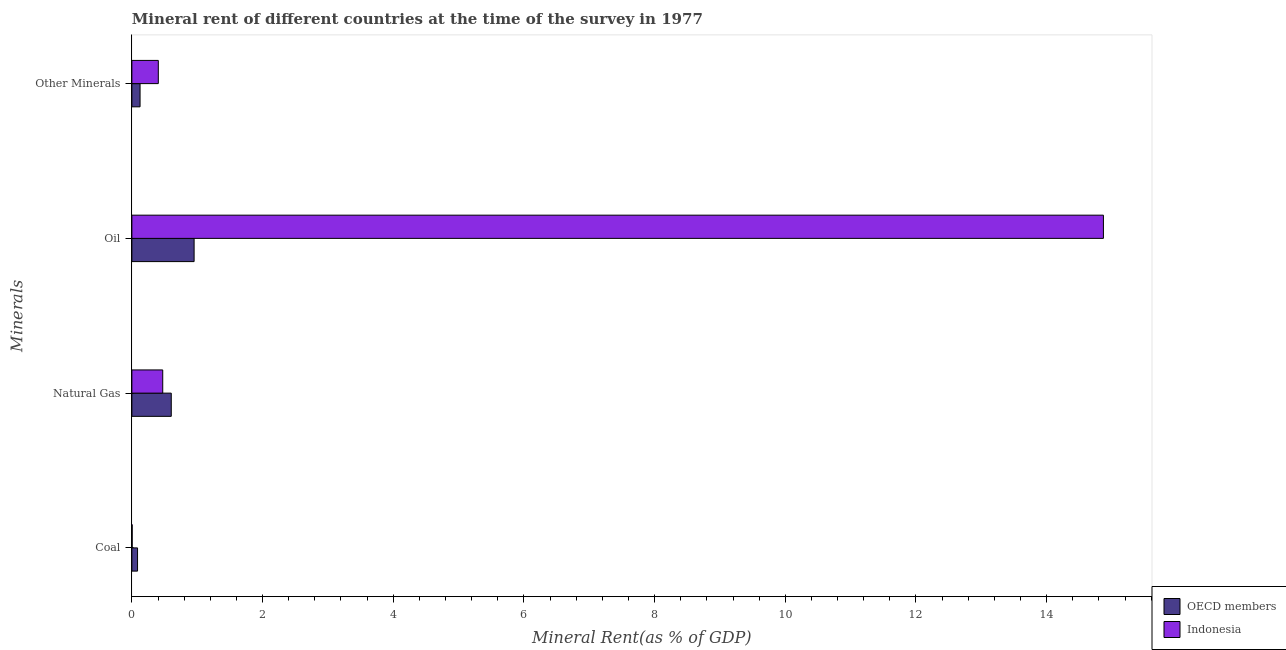How many groups of bars are there?
Offer a very short reply. 4. How many bars are there on the 3rd tick from the top?
Provide a short and direct response. 2. What is the label of the 1st group of bars from the top?
Your answer should be compact. Other Minerals. What is the natural gas rent in OECD members?
Your response must be concise. 0.6. Across all countries, what is the maximum natural gas rent?
Provide a short and direct response. 0.6. Across all countries, what is the minimum oil rent?
Provide a short and direct response. 0.95. In which country was the oil rent maximum?
Keep it short and to the point. Indonesia. What is the total coal rent in the graph?
Your response must be concise. 0.09. What is the difference between the  rent of other minerals in OECD members and that in Indonesia?
Make the answer very short. -0.28. What is the difference between the coal rent in OECD members and the oil rent in Indonesia?
Keep it short and to the point. -14.78. What is the average oil rent per country?
Offer a very short reply. 7.91. What is the difference between the  rent of other minerals and oil rent in Indonesia?
Your answer should be compact. -14.46. What is the ratio of the oil rent in Indonesia to that in OECD members?
Your response must be concise. 15.61. What is the difference between the highest and the second highest  rent of other minerals?
Offer a very short reply. 0.28. What is the difference between the highest and the lowest  rent of other minerals?
Give a very brief answer. 0.28. What does the 2nd bar from the top in Oil represents?
Provide a succinct answer. OECD members. Is it the case that in every country, the sum of the coal rent and natural gas rent is greater than the oil rent?
Your response must be concise. No. How many bars are there?
Offer a very short reply. 8. How many countries are there in the graph?
Keep it short and to the point. 2. Are the values on the major ticks of X-axis written in scientific E-notation?
Give a very brief answer. No. Does the graph contain any zero values?
Your answer should be very brief. No. How are the legend labels stacked?
Provide a succinct answer. Vertical. What is the title of the graph?
Your response must be concise. Mineral rent of different countries at the time of the survey in 1977. What is the label or title of the X-axis?
Your answer should be very brief. Mineral Rent(as % of GDP). What is the label or title of the Y-axis?
Ensure brevity in your answer.  Minerals. What is the Mineral Rent(as % of GDP) in OECD members in Coal?
Your answer should be very brief. 0.09. What is the Mineral Rent(as % of GDP) of Indonesia in Coal?
Ensure brevity in your answer.  0. What is the Mineral Rent(as % of GDP) of OECD members in Natural Gas?
Provide a succinct answer. 0.6. What is the Mineral Rent(as % of GDP) in Indonesia in Natural Gas?
Offer a terse response. 0.47. What is the Mineral Rent(as % of GDP) in OECD members in Oil?
Make the answer very short. 0.95. What is the Mineral Rent(as % of GDP) of Indonesia in Oil?
Offer a very short reply. 14.87. What is the Mineral Rent(as % of GDP) of OECD members in Other Minerals?
Make the answer very short. 0.13. What is the Mineral Rent(as % of GDP) of Indonesia in Other Minerals?
Provide a succinct answer. 0.4. Across all Minerals, what is the maximum Mineral Rent(as % of GDP) of OECD members?
Make the answer very short. 0.95. Across all Minerals, what is the maximum Mineral Rent(as % of GDP) of Indonesia?
Provide a succinct answer. 14.87. Across all Minerals, what is the minimum Mineral Rent(as % of GDP) in OECD members?
Your response must be concise. 0.09. Across all Minerals, what is the minimum Mineral Rent(as % of GDP) in Indonesia?
Make the answer very short. 0. What is the total Mineral Rent(as % of GDP) of OECD members in the graph?
Your answer should be compact. 1.77. What is the total Mineral Rent(as % of GDP) of Indonesia in the graph?
Offer a terse response. 15.75. What is the difference between the Mineral Rent(as % of GDP) in OECD members in Coal and that in Natural Gas?
Offer a very short reply. -0.52. What is the difference between the Mineral Rent(as % of GDP) of Indonesia in Coal and that in Natural Gas?
Offer a terse response. -0.47. What is the difference between the Mineral Rent(as % of GDP) in OECD members in Coal and that in Oil?
Offer a very short reply. -0.87. What is the difference between the Mineral Rent(as % of GDP) in Indonesia in Coal and that in Oil?
Your answer should be very brief. -14.86. What is the difference between the Mineral Rent(as % of GDP) of OECD members in Coal and that in Other Minerals?
Make the answer very short. -0.04. What is the difference between the Mineral Rent(as % of GDP) in OECD members in Natural Gas and that in Oil?
Provide a succinct answer. -0.35. What is the difference between the Mineral Rent(as % of GDP) in Indonesia in Natural Gas and that in Oil?
Your answer should be very brief. -14.4. What is the difference between the Mineral Rent(as % of GDP) of OECD members in Natural Gas and that in Other Minerals?
Keep it short and to the point. 0.48. What is the difference between the Mineral Rent(as % of GDP) of Indonesia in Natural Gas and that in Other Minerals?
Your answer should be very brief. 0.07. What is the difference between the Mineral Rent(as % of GDP) of OECD members in Oil and that in Other Minerals?
Give a very brief answer. 0.83. What is the difference between the Mineral Rent(as % of GDP) of Indonesia in Oil and that in Other Minerals?
Keep it short and to the point. 14.46. What is the difference between the Mineral Rent(as % of GDP) in OECD members in Coal and the Mineral Rent(as % of GDP) in Indonesia in Natural Gas?
Ensure brevity in your answer.  -0.39. What is the difference between the Mineral Rent(as % of GDP) of OECD members in Coal and the Mineral Rent(as % of GDP) of Indonesia in Oil?
Keep it short and to the point. -14.78. What is the difference between the Mineral Rent(as % of GDP) of OECD members in Coal and the Mineral Rent(as % of GDP) of Indonesia in Other Minerals?
Keep it short and to the point. -0.32. What is the difference between the Mineral Rent(as % of GDP) in OECD members in Natural Gas and the Mineral Rent(as % of GDP) in Indonesia in Oil?
Offer a terse response. -14.27. What is the difference between the Mineral Rent(as % of GDP) of OECD members in Natural Gas and the Mineral Rent(as % of GDP) of Indonesia in Other Minerals?
Give a very brief answer. 0.2. What is the difference between the Mineral Rent(as % of GDP) in OECD members in Oil and the Mineral Rent(as % of GDP) in Indonesia in Other Minerals?
Offer a terse response. 0.55. What is the average Mineral Rent(as % of GDP) of OECD members per Minerals?
Your response must be concise. 0.44. What is the average Mineral Rent(as % of GDP) in Indonesia per Minerals?
Make the answer very short. 3.94. What is the difference between the Mineral Rent(as % of GDP) in OECD members and Mineral Rent(as % of GDP) in Indonesia in Coal?
Your answer should be compact. 0.08. What is the difference between the Mineral Rent(as % of GDP) of OECD members and Mineral Rent(as % of GDP) of Indonesia in Natural Gas?
Make the answer very short. 0.13. What is the difference between the Mineral Rent(as % of GDP) of OECD members and Mineral Rent(as % of GDP) of Indonesia in Oil?
Offer a terse response. -13.92. What is the difference between the Mineral Rent(as % of GDP) in OECD members and Mineral Rent(as % of GDP) in Indonesia in Other Minerals?
Give a very brief answer. -0.28. What is the ratio of the Mineral Rent(as % of GDP) of OECD members in Coal to that in Natural Gas?
Keep it short and to the point. 0.14. What is the ratio of the Mineral Rent(as % of GDP) in Indonesia in Coal to that in Natural Gas?
Your answer should be very brief. 0.01. What is the ratio of the Mineral Rent(as % of GDP) in OECD members in Coal to that in Oil?
Your answer should be compact. 0.09. What is the ratio of the Mineral Rent(as % of GDP) in OECD members in Coal to that in Other Minerals?
Offer a very short reply. 0.69. What is the ratio of the Mineral Rent(as % of GDP) of Indonesia in Coal to that in Other Minerals?
Provide a short and direct response. 0.01. What is the ratio of the Mineral Rent(as % of GDP) of OECD members in Natural Gas to that in Oil?
Offer a very short reply. 0.63. What is the ratio of the Mineral Rent(as % of GDP) of Indonesia in Natural Gas to that in Oil?
Offer a terse response. 0.03. What is the ratio of the Mineral Rent(as % of GDP) in OECD members in Natural Gas to that in Other Minerals?
Your response must be concise. 4.81. What is the ratio of the Mineral Rent(as % of GDP) of Indonesia in Natural Gas to that in Other Minerals?
Provide a short and direct response. 1.17. What is the ratio of the Mineral Rent(as % of GDP) in OECD members in Oil to that in Other Minerals?
Keep it short and to the point. 7.6. What is the ratio of the Mineral Rent(as % of GDP) of Indonesia in Oil to that in Other Minerals?
Give a very brief answer. 36.75. What is the difference between the highest and the second highest Mineral Rent(as % of GDP) of OECD members?
Give a very brief answer. 0.35. What is the difference between the highest and the second highest Mineral Rent(as % of GDP) of Indonesia?
Give a very brief answer. 14.4. What is the difference between the highest and the lowest Mineral Rent(as % of GDP) in OECD members?
Your response must be concise. 0.87. What is the difference between the highest and the lowest Mineral Rent(as % of GDP) in Indonesia?
Give a very brief answer. 14.86. 